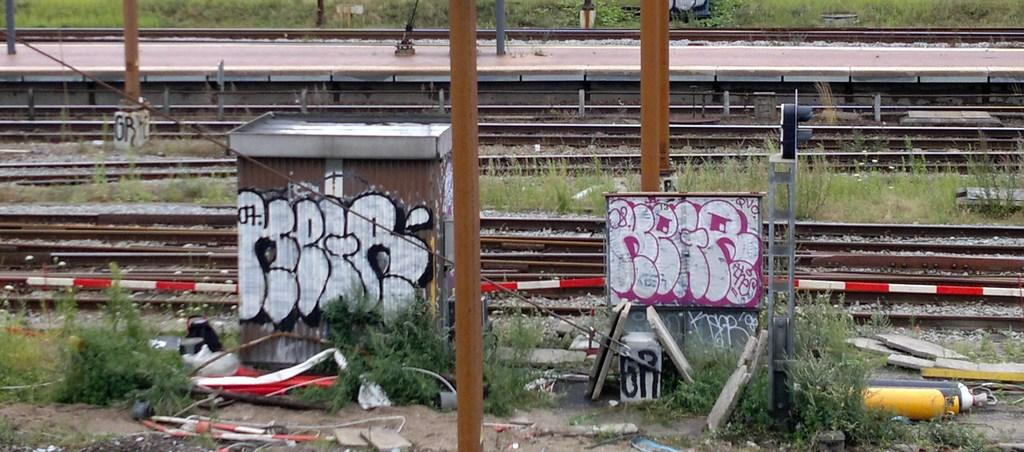What is the main object in the image? There is a box in the image. What other object can be seen in the image? There is a board in the image. What type of objects are on the ground in the image? There are metal objects on the ground in the image. What type of natural elements are present in the image? There are plants in the image. What can be seen in the background of the image? There are railway tracks and a platform in the background of the image. What type of record can be seen spinning on a plate in the image? There is no record or plate present in the image. What kind of bait is being used to catch fish in the image? There is no fishing or bait present in the image. 